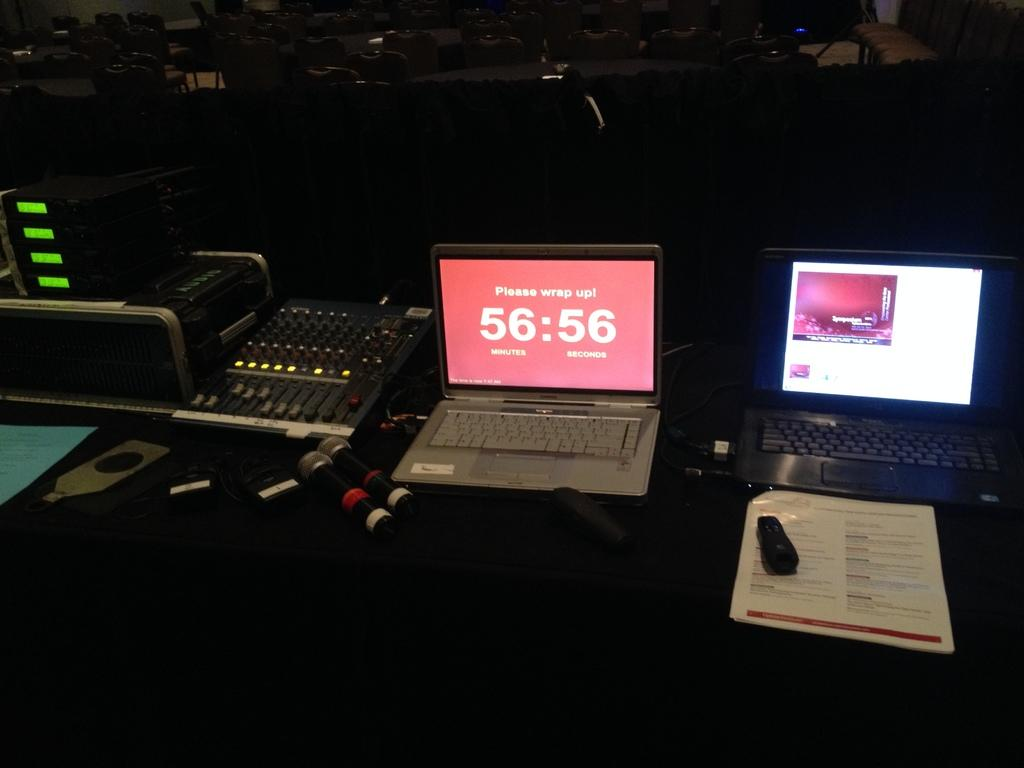<image>
Give a short and clear explanation of the subsequent image. A compute screen with a timer on displays minutes and seconds. 